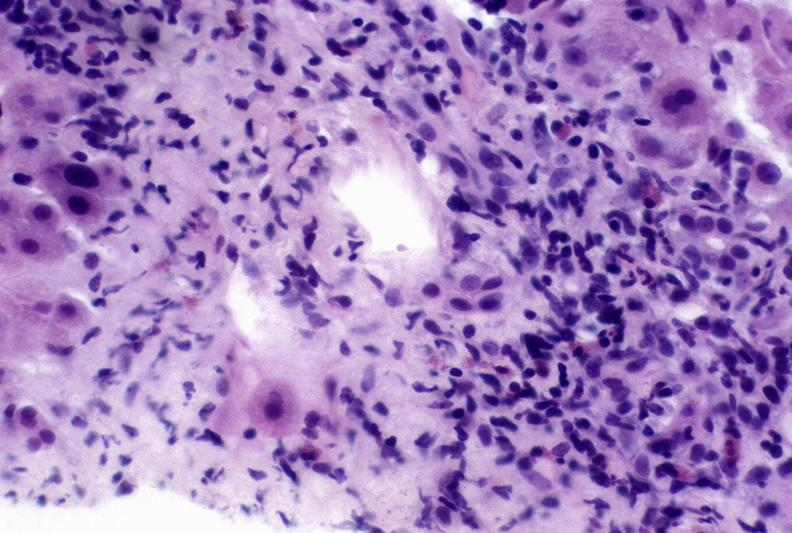s lymphangiomatosis generalized present?
Answer the question using a single word or phrase. No 